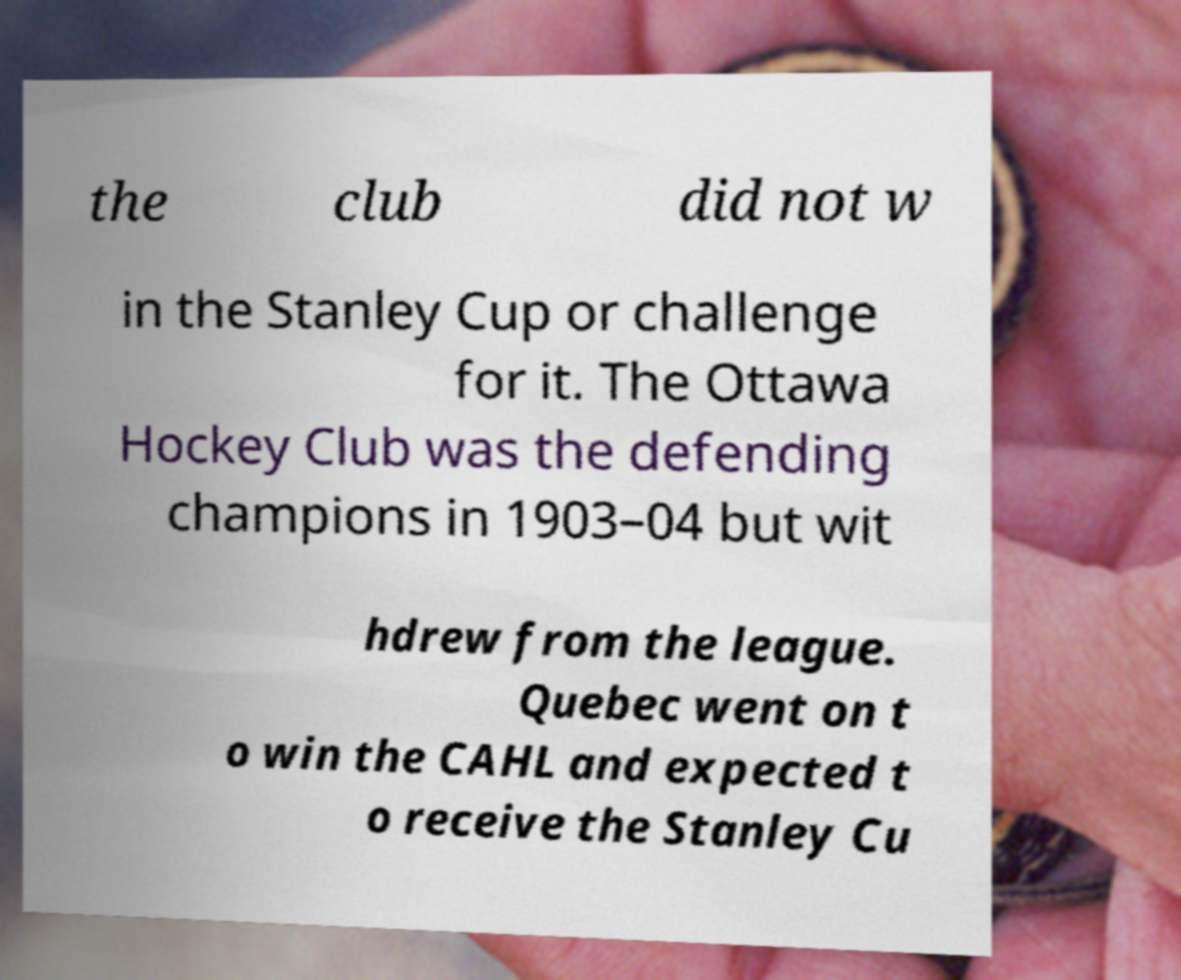What messages or text are displayed in this image? I need them in a readable, typed format. the club did not w in the Stanley Cup or challenge for it. The Ottawa Hockey Club was the defending champions in 1903–04 but wit hdrew from the league. Quebec went on t o win the CAHL and expected t o receive the Stanley Cu 